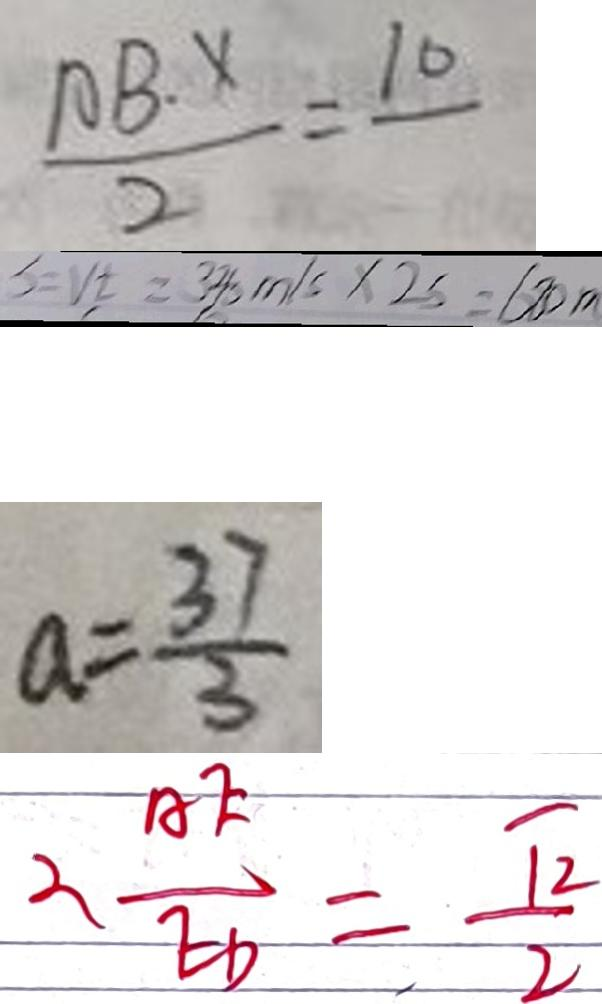<formula> <loc_0><loc_0><loc_500><loc_500>\frac { A B \cdot x } { 2 } = 1 0 
 S = V t = 3 3 8 m / s \times 2 s = 6 8 0 m 
 a = \frac { 3 7 } { 3 } 
 \therefore \frac { A E } { E D } = \frac { \sqrt { 2 } } { 2 }</formula> 